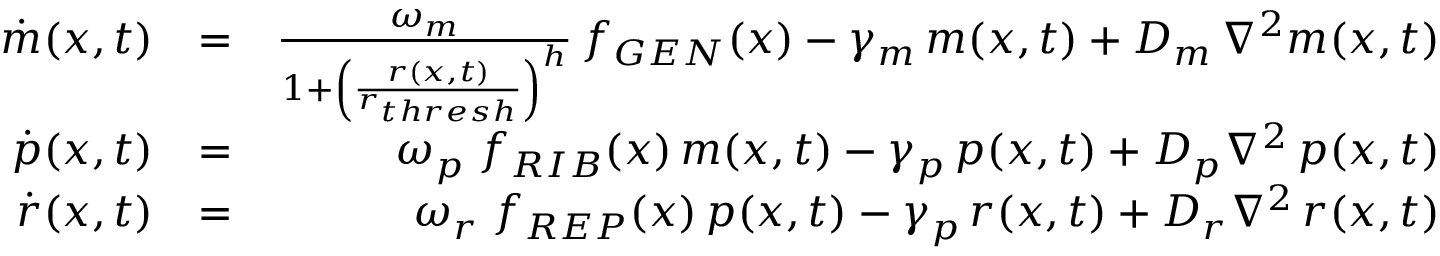<formula> <loc_0><loc_0><loc_500><loc_500>\begin{array} { r l r } { \dot { m } ( x , t ) } & { = } & { \frac { \omega _ { m } } { 1 + \left ( \frac { r ( x , t ) } { r _ { t h r e s h } } \right ) ^ { h } } \, f _ { G E N } ( x ) - \gamma _ { m } \, m ( x , t ) + D _ { m } \, \nabla ^ { 2 } m ( x , t ) } \\ { \dot { p } ( x , t ) } & { = } & { \omega _ { p } \, f _ { R I B } ( x ) \, m ( x , t ) - \gamma _ { p } \, p ( x , t ) + D _ { p } \nabla ^ { 2 } \, p ( x , t ) } \\ { \dot { r } ( x , t ) } & { = } & { \omega _ { r } \, f _ { R E P } ( x ) \, p ( x , t ) - \gamma _ { p } \, r ( x , t ) + D _ { r } \nabla ^ { 2 } \, r ( x , t ) } \end{array}</formula> 